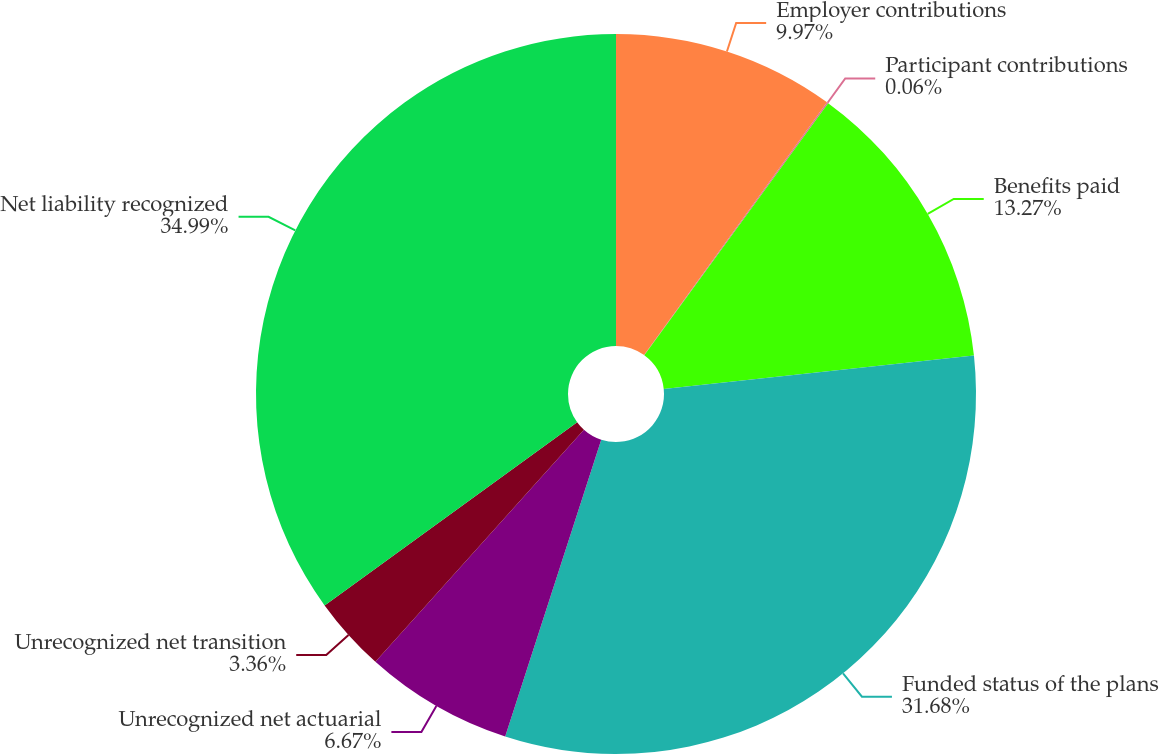<chart> <loc_0><loc_0><loc_500><loc_500><pie_chart><fcel>Employer contributions<fcel>Participant contributions<fcel>Benefits paid<fcel>Funded status of the plans<fcel>Unrecognized net actuarial<fcel>Unrecognized net transition<fcel>Net liability recognized<nl><fcel>9.97%<fcel>0.06%<fcel>13.27%<fcel>31.68%<fcel>6.67%<fcel>3.36%<fcel>34.99%<nl></chart> 